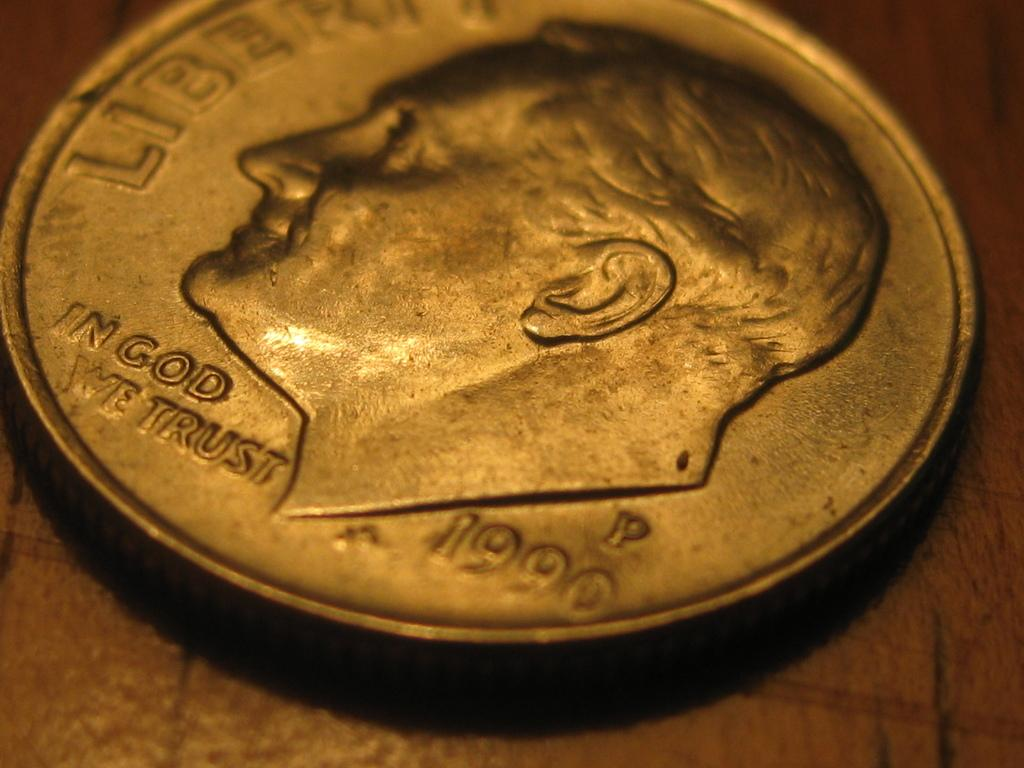<image>
Offer a succinct explanation of the picture presented. A coin with the year 1990 on it is face up on a table. 